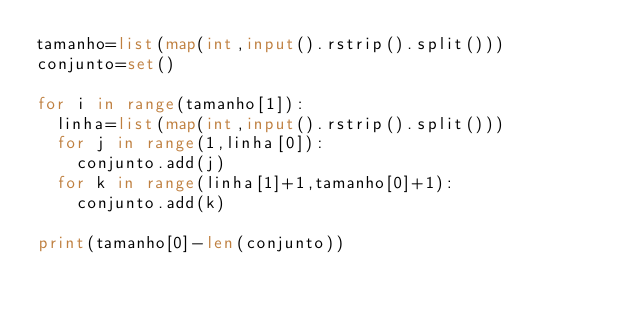<code> <loc_0><loc_0><loc_500><loc_500><_Python_>tamanho=list(map(int,input().rstrip().split()))
conjunto=set()

for i in range(tamanho[1]):
  linha=list(map(int,input().rstrip().split()))
  for j in range(1,linha[0]):
    conjunto.add(j)
  for k in range(linha[1]+1,tamanho[0]+1):
    conjunto.add(k)

print(tamanho[0]-len(conjunto))</code> 